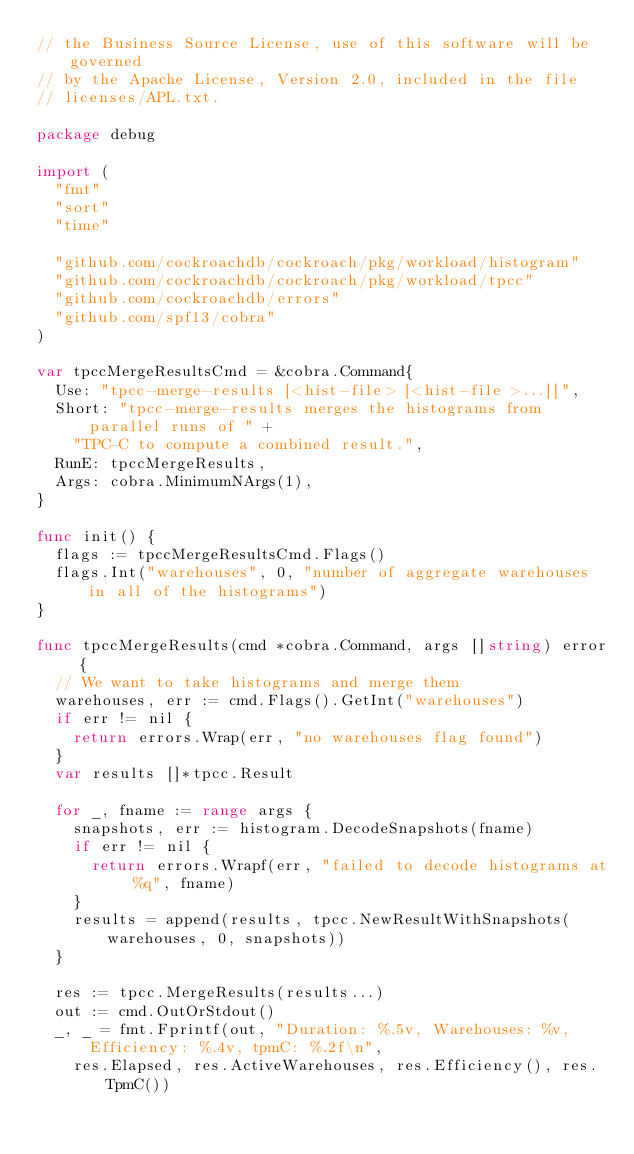Convert code to text. <code><loc_0><loc_0><loc_500><loc_500><_Go_>// the Business Source License, use of this software will be governed
// by the Apache License, Version 2.0, included in the file
// licenses/APL.txt.

package debug

import (
	"fmt"
	"sort"
	"time"

	"github.com/cockroachdb/cockroach/pkg/workload/histogram"
	"github.com/cockroachdb/cockroach/pkg/workload/tpcc"
	"github.com/cockroachdb/errors"
	"github.com/spf13/cobra"
)

var tpccMergeResultsCmd = &cobra.Command{
	Use: "tpcc-merge-results [<hist-file> [<hist-file>...]]",
	Short: "tpcc-merge-results merges the histograms from parallel runs of " +
		"TPC-C to compute a combined result.",
	RunE: tpccMergeResults,
	Args: cobra.MinimumNArgs(1),
}

func init() {
	flags := tpccMergeResultsCmd.Flags()
	flags.Int("warehouses", 0, "number of aggregate warehouses in all of the histograms")
}

func tpccMergeResults(cmd *cobra.Command, args []string) error {
	// We want to take histograms and merge them
	warehouses, err := cmd.Flags().GetInt("warehouses")
	if err != nil {
		return errors.Wrap(err, "no warehouses flag found")
	}
	var results []*tpcc.Result

	for _, fname := range args {
		snapshots, err := histogram.DecodeSnapshots(fname)
		if err != nil {
			return errors.Wrapf(err, "failed to decode histograms at %q", fname)
		}
		results = append(results, tpcc.NewResultWithSnapshots(warehouses, 0, snapshots))
	}

	res := tpcc.MergeResults(results...)
	out := cmd.OutOrStdout()
	_, _ = fmt.Fprintf(out, "Duration: %.5v, Warehouses: %v, Efficiency: %.4v, tpmC: %.2f\n",
		res.Elapsed, res.ActiveWarehouses, res.Efficiency(), res.TpmC())</code> 